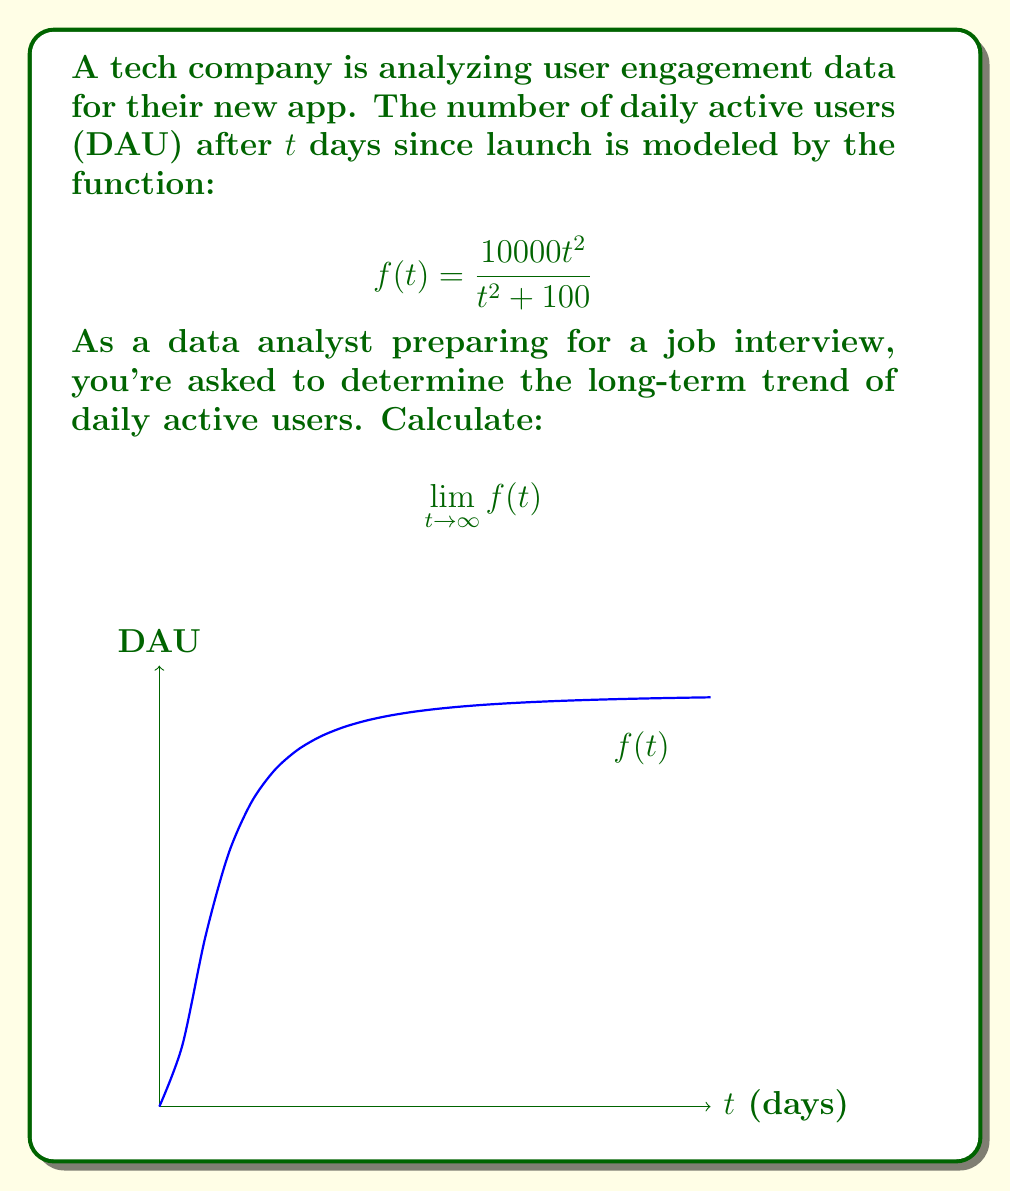Provide a solution to this math problem. To evaluate this limit, we'll follow these steps:

1) First, let's examine the function:
   $$f(t) = \frac{10000t^2}{t^2 + 100}$$

2) As $t$ approaches infinity, both the numerator and denominator grow without bound. This is an indeterminate form of type $\frac{\infty}{\infty}$.

3) To resolve this, we can divide both the numerator and denominator by the highest power of $t$ in the denominator, which is $t^2$:

   $$\lim_{t \to \infty} f(t) = \lim_{t \to \infty} \frac{10000t^2}{t^2 + 100} = \lim_{t \to \infty} \frac{10000\frac{t^2}{t^2}}{\frac{t^2}{t^2} + \frac{100}{t^2}}$$

4) Simplify:
   $$\lim_{t \to \infty} \frac{10000}{1 + \frac{100}{t^2}}$$

5) As $t$ approaches infinity, $\frac{100}{t^2}$ approaches 0:
   $$\lim_{t \to \infty} \frac{10000}{1 + 0} = 10000$$

Therefore, the long-term trend shows that the number of daily active users approaches 10,000 as time goes to infinity.
Answer: 10000 